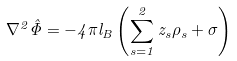<formula> <loc_0><loc_0><loc_500><loc_500>\nabla ^ { 2 } \hat { \Phi } = - 4 \pi l _ { B } \left ( \sum _ { s = 1 } ^ { 2 } z _ { s } \rho _ { s } + \sigma \right )</formula> 